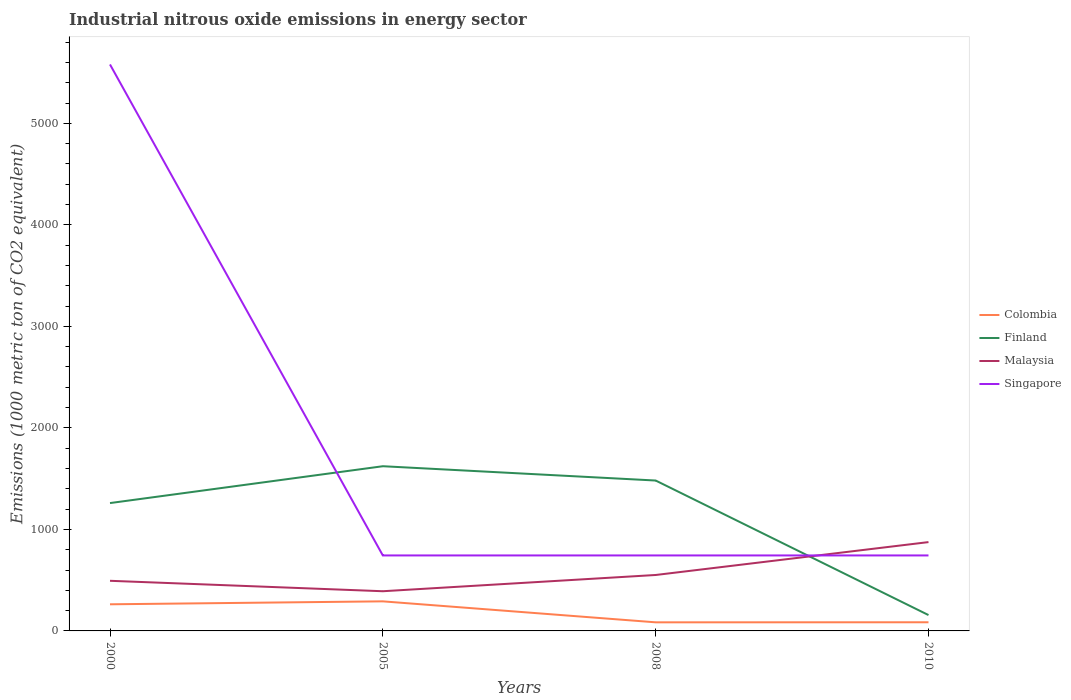Does the line corresponding to Finland intersect with the line corresponding to Malaysia?
Your answer should be compact. Yes. Is the number of lines equal to the number of legend labels?
Offer a very short reply. Yes. Across all years, what is the maximum amount of industrial nitrous oxide emitted in Singapore?
Your answer should be compact. 743.5. What is the total amount of industrial nitrous oxide emitted in Malaysia in the graph?
Your answer should be compact. -160.1. What is the difference between the highest and the second highest amount of industrial nitrous oxide emitted in Finland?
Provide a succinct answer. 1466.1. Is the amount of industrial nitrous oxide emitted in Finland strictly greater than the amount of industrial nitrous oxide emitted in Colombia over the years?
Ensure brevity in your answer.  No. How many years are there in the graph?
Ensure brevity in your answer.  4. Are the values on the major ticks of Y-axis written in scientific E-notation?
Ensure brevity in your answer.  No. Does the graph contain any zero values?
Your response must be concise. No. Does the graph contain grids?
Keep it short and to the point. No. How are the legend labels stacked?
Make the answer very short. Vertical. What is the title of the graph?
Provide a succinct answer. Industrial nitrous oxide emissions in energy sector. What is the label or title of the X-axis?
Your answer should be very brief. Years. What is the label or title of the Y-axis?
Ensure brevity in your answer.  Emissions (1000 metric ton of CO2 equivalent). What is the Emissions (1000 metric ton of CO2 equivalent) in Colombia in 2000?
Keep it short and to the point. 262.3. What is the Emissions (1000 metric ton of CO2 equivalent) in Finland in 2000?
Provide a short and direct response. 1259.4. What is the Emissions (1000 metric ton of CO2 equivalent) of Malaysia in 2000?
Make the answer very short. 493.8. What is the Emissions (1000 metric ton of CO2 equivalent) in Singapore in 2000?
Provide a short and direct response. 5580. What is the Emissions (1000 metric ton of CO2 equivalent) of Colombia in 2005?
Your response must be concise. 291.3. What is the Emissions (1000 metric ton of CO2 equivalent) of Finland in 2005?
Your answer should be very brief. 1622.4. What is the Emissions (1000 metric ton of CO2 equivalent) in Malaysia in 2005?
Provide a succinct answer. 390.9. What is the Emissions (1000 metric ton of CO2 equivalent) of Singapore in 2005?
Your answer should be compact. 743.5. What is the Emissions (1000 metric ton of CO2 equivalent) of Colombia in 2008?
Offer a very short reply. 84.7. What is the Emissions (1000 metric ton of CO2 equivalent) of Finland in 2008?
Ensure brevity in your answer.  1481.5. What is the Emissions (1000 metric ton of CO2 equivalent) of Malaysia in 2008?
Make the answer very short. 551. What is the Emissions (1000 metric ton of CO2 equivalent) of Singapore in 2008?
Offer a terse response. 743.5. What is the Emissions (1000 metric ton of CO2 equivalent) of Colombia in 2010?
Your answer should be compact. 85.2. What is the Emissions (1000 metric ton of CO2 equivalent) in Finland in 2010?
Offer a terse response. 156.3. What is the Emissions (1000 metric ton of CO2 equivalent) in Malaysia in 2010?
Your answer should be very brief. 874.9. What is the Emissions (1000 metric ton of CO2 equivalent) of Singapore in 2010?
Offer a terse response. 743.5. Across all years, what is the maximum Emissions (1000 metric ton of CO2 equivalent) in Colombia?
Provide a succinct answer. 291.3. Across all years, what is the maximum Emissions (1000 metric ton of CO2 equivalent) of Finland?
Keep it short and to the point. 1622.4. Across all years, what is the maximum Emissions (1000 metric ton of CO2 equivalent) of Malaysia?
Your answer should be compact. 874.9. Across all years, what is the maximum Emissions (1000 metric ton of CO2 equivalent) of Singapore?
Your answer should be compact. 5580. Across all years, what is the minimum Emissions (1000 metric ton of CO2 equivalent) of Colombia?
Keep it short and to the point. 84.7. Across all years, what is the minimum Emissions (1000 metric ton of CO2 equivalent) in Finland?
Your response must be concise. 156.3. Across all years, what is the minimum Emissions (1000 metric ton of CO2 equivalent) of Malaysia?
Provide a short and direct response. 390.9. Across all years, what is the minimum Emissions (1000 metric ton of CO2 equivalent) of Singapore?
Offer a very short reply. 743.5. What is the total Emissions (1000 metric ton of CO2 equivalent) in Colombia in the graph?
Make the answer very short. 723.5. What is the total Emissions (1000 metric ton of CO2 equivalent) of Finland in the graph?
Offer a very short reply. 4519.6. What is the total Emissions (1000 metric ton of CO2 equivalent) in Malaysia in the graph?
Provide a succinct answer. 2310.6. What is the total Emissions (1000 metric ton of CO2 equivalent) of Singapore in the graph?
Offer a very short reply. 7810.5. What is the difference between the Emissions (1000 metric ton of CO2 equivalent) in Finland in 2000 and that in 2005?
Your response must be concise. -363. What is the difference between the Emissions (1000 metric ton of CO2 equivalent) in Malaysia in 2000 and that in 2005?
Ensure brevity in your answer.  102.9. What is the difference between the Emissions (1000 metric ton of CO2 equivalent) of Singapore in 2000 and that in 2005?
Ensure brevity in your answer.  4836.5. What is the difference between the Emissions (1000 metric ton of CO2 equivalent) in Colombia in 2000 and that in 2008?
Give a very brief answer. 177.6. What is the difference between the Emissions (1000 metric ton of CO2 equivalent) in Finland in 2000 and that in 2008?
Offer a terse response. -222.1. What is the difference between the Emissions (1000 metric ton of CO2 equivalent) in Malaysia in 2000 and that in 2008?
Provide a short and direct response. -57.2. What is the difference between the Emissions (1000 metric ton of CO2 equivalent) of Singapore in 2000 and that in 2008?
Keep it short and to the point. 4836.5. What is the difference between the Emissions (1000 metric ton of CO2 equivalent) of Colombia in 2000 and that in 2010?
Provide a short and direct response. 177.1. What is the difference between the Emissions (1000 metric ton of CO2 equivalent) of Finland in 2000 and that in 2010?
Make the answer very short. 1103.1. What is the difference between the Emissions (1000 metric ton of CO2 equivalent) of Malaysia in 2000 and that in 2010?
Offer a terse response. -381.1. What is the difference between the Emissions (1000 metric ton of CO2 equivalent) in Singapore in 2000 and that in 2010?
Make the answer very short. 4836.5. What is the difference between the Emissions (1000 metric ton of CO2 equivalent) of Colombia in 2005 and that in 2008?
Offer a terse response. 206.6. What is the difference between the Emissions (1000 metric ton of CO2 equivalent) in Finland in 2005 and that in 2008?
Give a very brief answer. 140.9. What is the difference between the Emissions (1000 metric ton of CO2 equivalent) of Malaysia in 2005 and that in 2008?
Provide a short and direct response. -160.1. What is the difference between the Emissions (1000 metric ton of CO2 equivalent) in Singapore in 2005 and that in 2008?
Provide a succinct answer. 0. What is the difference between the Emissions (1000 metric ton of CO2 equivalent) in Colombia in 2005 and that in 2010?
Your response must be concise. 206.1. What is the difference between the Emissions (1000 metric ton of CO2 equivalent) of Finland in 2005 and that in 2010?
Offer a very short reply. 1466.1. What is the difference between the Emissions (1000 metric ton of CO2 equivalent) in Malaysia in 2005 and that in 2010?
Provide a short and direct response. -484. What is the difference between the Emissions (1000 metric ton of CO2 equivalent) of Singapore in 2005 and that in 2010?
Offer a very short reply. 0. What is the difference between the Emissions (1000 metric ton of CO2 equivalent) in Finland in 2008 and that in 2010?
Offer a very short reply. 1325.2. What is the difference between the Emissions (1000 metric ton of CO2 equivalent) in Malaysia in 2008 and that in 2010?
Keep it short and to the point. -323.9. What is the difference between the Emissions (1000 metric ton of CO2 equivalent) of Singapore in 2008 and that in 2010?
Keep it short and to the point. 0. What is the difference between the Emissions (1000 metric ton of CO2 equivalent) in Colombia in 2000 and the Emissions (1000 metric ton of CO2 equivalent) in Finland in 2005?
Offer a very short reply. -1360.1. What is the difference between the Emissions (1000 metric ton of CO2 equivalent) of Colombia in 2000 and the Emissions (1000 metric ton of CO2 equivalent) of Malaysia in 2005?
Provide a succinct answer. -128.6. What is the difference between the Emissions (1000 metric ton of CO2 equivalent) of Colombia in 2000 and the Emissions (1000 metric ton of CO2 equivalent) of Singapore in 2005?
Offer a terse response. -481.2. What is the difference between the Emissions (1000 metric ton of CO2 equivalent) in Finland in 2000 and the Emissions (1000 metric ton of CO2 equivalent) in Malaysia in 2005?
Give a very brief answer. 868.5. What is the difference between the Emissions (1000 metric ton of CO2 equivalent) of Finland in 2000 and the Emissions (1000 metric ton of CO2 equivalent) of Singapore in 2005?
Your answer should be very brief. 515.9. What is the difference between the Emissions (1000 metric ton of CO2 equivalent) in Malaysia in 2000 and the Emissions (1000 metric ton of CO2 equivalent) in Singapore in 2005?
Your answer should be very brief. -249.7. What is the difference between the Emissions (1000 metric ton of CO2 equivalent) in Colombia in 2000 and the Emissions (1000 metric ton of CO2 equivalent) in Finland in 2008?
Offer a very short reply. -1219.2. What is the difference between the Emissions (1000 metric ton of CO2 equivalent) in Colombia in 2000 and the Emissions (1000 metric ton of CO2 equivalent) in Malaysia in 2008?
Offer a terse response. -288.7. What is the difference between the Emissions (1000 metric ton of CO2 equivalent) in Colombia in 2000 and the Emissions (1000 metric ton of CO2 equivalent) in Singapore in 2008?
Your answer should be compact. -481.2. What is the difference between the Emissions (1000 metric ton of CO2 equivalent) of Finland in 2000 and the Emissions (1000 metric ton of CO2 equivalent) of Malaysia in 2008?
Offer a terse response. 708.4. What is the difference between the Emissions (1000 metric ton of CO2 equivalent) in Finland in 2000 and the Emissions (1000 metric ton of CO2 equivalent) in Singapore in 2008?
Your answer should be very brief. 515.9. What is the difference between the Emissions (1000 metric ton of CO2 equivalent) in Malaysia in 2000 and the Emissions (1000 metric ton of CO2 equivalent) in Singapore in 2008?
Provide a short and direct response. -249.7. What is the difference between the Emissions (1000 metric ton of CO2 equivalent) of Colombia in 2000 and the Emissions (1000 metric ton of CO2 equivalent) of Finland in 2010?
Offer a terse response. 106. What is the difference between the Emissions (1000 metric ton of CO2 equivalent) in Colombia in 2000 and the Emissions (1000 metric ton of CO2 equivalent) in Malaysia in 2010?
Provide a short and direct response. -612.6. What is the difference between the Emissions (1000 metric ton of CO2 equivalent) of Colombia in 2000 and the Emissions (1000 metric ton of CO2 equivalent) of Singapore in 2010?
Your response must be concise. -481.2. What is the difference between the Emissions (1000 metric ton of CO2 equivalent) in Finland in 2000 and the Emissions (1000 metric ton of CO2 equivalent) in Malaysia in 2010?
Your answer should be very brief. 384.5. What is the difference between the Emissions (1000 metric ton of CO2 equivalent) in Finland in 2000 and the Emissions (1000 metric ton of CO2 equivalent) in Singapore in 2010?
Ensure brevity in your answer.  515.9. What is the difference between the Emissions (1000 metric ton of CO2 equivalent) in Malaysia in 2000 and the Emissions (1000 metric ton of CO2 equivalent) in Singapore in 2010?
Make the answer very short. -249.7. What is the difference between the Emissions (1000 metric ton of CO2 equivalent) in Colombia in 2005 and the Emissions (1000 metric ton of CO2 equivalent) in Finland in 2008?
Offer a terse response. -1190.2. What is the difference between the Emissions (1000 metric ton of CO2 equivalent) in Colombia in 2005 and the Emissions (1000 metric ton of CO2 equivalent) in Malaysia in 2008?
Your response must be concise. -259.7. What is the difference between the Emissions (1000 metric ton of CO2 equivalent) in Colombia in 2005 and the Emissions (1000 metric ton of CO2 equivalent) in Singapore in 2008?
Make the answer very short. -452.2. What is the difference between the Emissions (1000 metric ton of CO2 equivalent) of Finland in 2005 and the Emissions (1000 metric ton of CO2 equivalent) of Malaysia in 2008?
Offer a terse response. 1071.4. What is the difference between the Emissions (1000 metric ton of CO2 equivalent) in Finland in 2005 and the Emissions (1000 metric ton of CO2 equivalent) in Singapore in 2008?
Your answer should be compact. 878.9. What is the difference between the Emissions (1000 metric ton of CO2 equivalent) of Malaysia in 2005 and the Emissions (1000 metric ton of CO2 equivalent) of Singapore in 2008?
Keep it short and to the point. -352.6. What is the difference between the Emissions (1000 metric ton of CO2 equivalent) in Colombia in 2005 and the Emissions (1000 metric ton of CO2 equivalent) in Finland in 2010?
Offer a terse response. 135. What is the difference between the Emissions (1000 metric ton of CO2 equivalent) in Colombia in 2005 and the Emissions (1000 metric ton of CO2 equivalent) in Malaysia in 2010?
Ensure brevity in your answer.  -583.6. What is the difference between the Emissions (1000 metric ton of CO2 equivalent) of Colombia in 2005 and the Emissions (1000 metric ton of CO2 equivalent) of Singapore in 2010?
Ensure brevity in your answer.  -452.2. What is the difference between the Emissions (1000 metric ton of CO2 equivalent) of Finland in 2005 and the Emissions (1000 metric ton of CO2 equivalent) of Malaysia in 2010?
Keep it short and to the point. 747.5. What is the difference between the Emissions (1000 metric ton of CO2 equivalent) of Finland in 2005 and the Emissions (1000 metric ton of CO2 equivalent) of Singapore in 2010?
Give a very brief answer. 878.9. What is the difference between the Emissions (1000 metric ton of CO2 equivalent) of Malaysia in 2005 and the Emissions (1000 metric ton of CO2 equivalent) of Singapore in 2010?
Provide a short and direct response. -352.6. What is the difference between the Emissions (1000 metric ton of CO2 equivalent) in Colombia in 2008 and the Emissions (1000 metric ton of CO2 equivalent) in Finland in 2010?
Your answer should be compact. -71.6. What is the difference between the Emissions (1000 metric ton of CO2 equivalent) in Colombia in 2008 and the Emissions (1000 metric ton of CO2 equivalent) in Malaysia in 2010?
Provide a succinct answer. -790.2. What is the difference between the Emissions (1000 metric ton of CO2 equivalent) of Colombia in 2008 and the Emissions (1000 metric ton of CO2 equivalent) of Singapore in 2010?
Offer a very short reply. -658.8. What is the difference between the Emissions (1000 metric ton of CO2 equivalent) of Finland in 2008 and the Emissions (1000 metric ton of CO2 equivalent) of Malaysia in 2010?
Provide a succinct answer. 606.6. What is the difference between the Emissions (1000 metric ton of CO2 equivalent) of Finland in 2008 and the Emissions (1000 metric ton of CO2 equivalent) of Singapore in 2010?
Your answer should be compact. 738. What is the difference between the Emissions (1000 metric ton of CO2 equivalent) in Malaysia in 2008 and the Emissions (1000 metric ton of CO2 equivalent) in Singapore in 2010?
Your answer should be very brief. -192.5. What is the average Emissions (1000 metric ton of CO2 equivalent) of Colombia per year?
Your response must be concise. 180.88. What is the average Emissions (1000 metric ton of CO2 equivalent) in Finland per year?
Ensure brevity in your answer.  1129.9. What is the average Emissions (1000 metric ton of CO2 equivalent) of Malaysia per year?
Make the answer very short. 577.65. What is the average Emissions (1000 metric ton of CO2 equivalent) in Singapore per year?
Your answer should be compact. 1952.62. In the year 2000, what is the difference between the Emissions (1000 metric ton of CO2 equivalent) of Colombia and Emissions (1000 metric ton of CO2 equivalent) of Finland?
Provide a succinct answer. -997.1. In the year 2000, what is the difference between the Emissions (1000 metric ton of CO2 equivalent) of Colombia and Emissions (1000 metric ton of CO2 equivalent) of Malaysia?
Offer a very short reply. -231.5. In the year 2000, what is the difference between the Emissions (1000 metric ton of CO2 equivalent) in Colombia and Emissions (1000 metric ton of CO2 equivalent) in Singapore?
Keep it short and to the point. -5317.7. In the year 2000, what is the difference between the Emissions (1000 metric ton of CO2 equivalent) of Finland and Emissions (1000 metric ton of CO2 equivalent) of Malaysia?
Make the answer very short. 765.6. In the year 2000, what is the difference between the Emissions (1000 metric ton of CO2 equivalent) in Finland and Emissions (1000 metric ton of CO2 equivalent) in Singapore?
Ensure brevity in your answer.  -4320.6. In the year 2000, what is the difference between the Emissions (1000 metric ton of CO2 equivalent) of Malaysia and Emissions (1000 metric ton of CO2 equivalent) of Singapore?
Make the answer very short. -5086.2. In the year 2005, what is the difference between the Emissions (1000 metric ton of CO2 equivalent) of Colombia and Emissions (1000 metric ton of CO2 equivalent) of Finland?
Keep it short and to the point. -1331.1. In the year 2005, what is the difference between the Emissions (1000 metric ton of CO2 equivalent) in Colombia and Emissions (1000 metric ton of CO2 equivalent) in Malaysia?
Give a very brief answer. -99.6. In the year 2005, what is the difference between the Emissions (1000 metric ton of CO2 equivalent) in Colombia and Emissions (1000 metric ton of CO2 equivalent) in Singapore?
Your answer should be compact. -452.2. In the year 2005, what is the difference between the Emissions (1000 metric ton of CO2 equivalent) of Finland and Emissions (1000 metric ton of CO2 equivalent) of Malaysia?
Make the answer very short. 1231.5. In the year 2005, what is the difference between the Emissions (1000 metric ton of CO2 equivalent) of Finland and Emissions (1000 metric ton of CO2 equivalent) of Singapore?
Make the answer very short. 878.9. In the year 2005, what is the difference between the Emissions (1000 metric ton of CO2 equivalent) of Malaysia and Emissions (1000 metric ton of CO2 equivalent) of Singapore?
Keep it short and to the point. -352.6. In the year 2008, what is the difference between the Emissions (1000 metric ton of CO2 equivalent) in Colombia and Emissions (1000 metric ton of CO2 equivalent) in Finland?
Ensure brevity in your answer.  -1396.8. In the year 2008, what is the difference between the Emissions (1000 metric ton of CO2 equivalent) in Colombia and Emissions (1000 metric ton of CO2 equivalent) in Malaysia?
Keep it short and to the point. -466.3. In the year 2008, what is the difference between the Emissions (1000 metric ton of CO2 equivalent) of Colombia and Emissions (1000 metric ton of CO2 equivalent) of Singapore?
Your answer should be compact. -658.8. In the year 2008, what is the difference between the Emissions (1000 metric ton of CO2 equivalent) in Finland and Emissions (1000 metric ton of CO2 equivalent) in Malaysia?
Your answer should be very brief. 930.5. In the year 2008, what is the difference between the Emissions (1000 metric ton of CO2 equivalent) in Finland and Emissions (1000 metric ton of CO2 equivalent) in Singapore?
Make the answer very short. 738. In the year 2008, what is the difference between the Emissions (1000 metric ton of CO2 equivalent) in Malaysia and Emissions (1000 metric ton of CO2 equivalent) in Singapore?
Give a very brief answer. -192.5. In the year 2010, what is the difference between the Emissions (1000 metric ton of CO2 equivalent) in Colombia and Emissions (1000 metric ton of CO2 equivalent) in Finland?
Your answer should be very brief. -71.1. In the year 2010, what is the difference between the Emissions (1000 metric ton of CO2 equivalent) of Colombia and Emissions (1000 metric ton of CO2 equivalent) of Malaysia?
Offer a very short reply. -789.7. In the year 2010, what is the difference between the Emissions (1000 metric ton of CO2 equivalent) of Colombia and Emissions (1000 metric ton of CO2 equivalent) of Singapore?
Provide a succinct answer. -658.3. In the year 2010, what is the difference between the Emissions (1000 metric ton of CO2 equivalent) in Finland and Emissions (1000 metric ton of CO2 equivalent) in Malaysia?
Give a very brief answer. -718.6. In the year 2010, what is the difference between the Emissions (1000 metric ton of CO2 equivalent) of Finland and Emissions (1000 metric ton of CO2 equivalent) of Singapore?
Provide a short and direct response. -587.2. In the year 2010, what is the difference between the Emissions (1000 metric ton of CO2 equivalent) of Malaysia and Emissions (1000 metric ton of CO2 equivalent) of Singapore?
Your answer should be very brief. 131.4. What is the ratio of the Emissions (1000 metric ton of CO2 equivalent) of Colombia in 2000 to that in 2005?
Your answer should be very brief. 0.9. What is the ratio of the Emissions (1000 metric ton of CO2 equivalent) of Finland in 2000 to that in 2005?
Give a very brief answer. 0.78. What is the ratio of the Emissions (1000 metric ton of CO2 equivalent) in Malaysia in 2000 to that in 2005?
Your answer should be compact. 1.26. What is the ratio of the Emissions (1000 metric ton of CO2 equivalent) in Singapore in 2000 to that in 2005?
Ensure brevity in your answer.  7.5. What is the ratio of the Emissions (1000 metric ton of CO2 equivalent) in Colombia in 2000 to that in 2008?
Give a very brief answer. 3.1. What is the ratio of the Emissions (1000 metric ton of CO2 equivalent) of Finland in 2000 to that in 2008?
Offer a terse response. 0.85. What is the ratio of the Emissions (1000 metric ton of CO2 equivalent) of Malaysia in 2000 to that in 2008?
Your response must be concise. 0.9. What is the ratio of the Emissions (1000 metric ton of CO2 equivalent) of Singapore in 2000 to that in 2008?
Keep it short and to the point. 7.5. What is the ratio of the Emissions (1000 metric ton of CO2 equivalent) in Colombia in 2000 to that in 2010?
Keep it short and to the point. 3.08. What is the ratio of the Emissions (1000 metric ton of CO2 equivalent) in Finland in 2000 to that in 2010?
Offer a very short reply. 8.06. What is the ratio of the Emissions (1000 metric ton of CO2 equivalent) in Malaysia in 2000 to that in 2010?
Offer a very short reply. 0.56. What is the ratio of the Emissions (1000 metric ton of CO2 equivalent) in Singapore in 2000 to that in 2010?
Ensure brevity in your answer.  7.5. What is the ratio of the Emissions (1000 metric ton of CO2 equivalent) in Colombia in 2005 to that in 2008?
Offer a terse response. 3.44. What is the ratio of the Emissions (1000 metric ton of CO2 equivalent) in Finland in 2005 to that in 2008?
Make the answer very short. 1.1. What is the ratio of the Emissions (1000 metric ton of CO2 equivalent) in Malaysia in 2005 to that in 2008?
Provide a succinct answer. 0.71. What is the ratio of the Emissions (1000 metric ton of CO2 equivalent) of Singapore in 2005 to that in 2008?
Your answer should be compact. 1. What is the ratio of the Emissions (1000 metric ton of CO2 equivalent) in Colombia in 2005 to that in 2010?
Offer a very short reply. 3.42. What is the ratio of the Emissions (1000 metric ton of CO2 equivalent) of Finland in 2005 to that in 2010?
Keep it short and to the point. 10.38. What is the ratio of the Emissions (1000 metric ton of CO2 equivalent) of Malaysia in 2005 to that in 2010?
Your answer should be compact. 0.45. What is the ratio of the Emissions (1000 metric ton of CO2 equivalent) of Singapore in 2005 to that in 2010?
Provide a short and direct response. 1. What is the ratio of the Emissions (1000 metric ton of CO2 equivalent) in Colombia in 2008 to that in 2010?
Ensure brevity in your answer.  0.99. What is the ratio of the Emissions (1000 metric ton of CO2 equivalent) of Finland in 2008 to that in 2010?
Your response must be concise. 9.48. What is the ratio of the Emissions (1000 metric ton of CO2 equivalent) in Malaysia in 2008 to that in 2010?
Your answer should be very brief. 0.63. What is the ratio of the Emissions (1000 metric ton of CO2 equivalent) in Singapore in 2008 to that in 2010?
Offer a terse response. 1. What is the difference between the highest and the second highest Emissions (1000 metric ton of CO2 equivalent) of Finland?
Offer a terse response. 140.9. What is the difference between the highest and the second highest Emissions (1000 metric ton of CO2 equivalent) of Malaysia?
Offer a terse response. 323.9. What is the difference between the highest and the second highest Emissions (1000 metric ton of CO2 equivalent) in Singapore?
Provide a short and direct response. 4836.5. What is the difference between the highest and the lowest Emissions (1000 metric ton of CO2 equivalent) of Colombia?
Give a very brief answer. 206.6. What is the difference between the highest and the lowest Emissions (1000 metric ton of CO2 equivalent) in Finland?
Ensure brevity in your answer.  1466.1. What is the difference between the highest and the lowest Emissions (1000 metric ton of CO2 equivalent) of Malaysia?
Ensure brevity in your answer.  484. What is the difference between the highest and the lowest Emissions (1000 metric ton of CO2 equivalent) of Singapore?
Provide a succinct answer. 4836.5. 